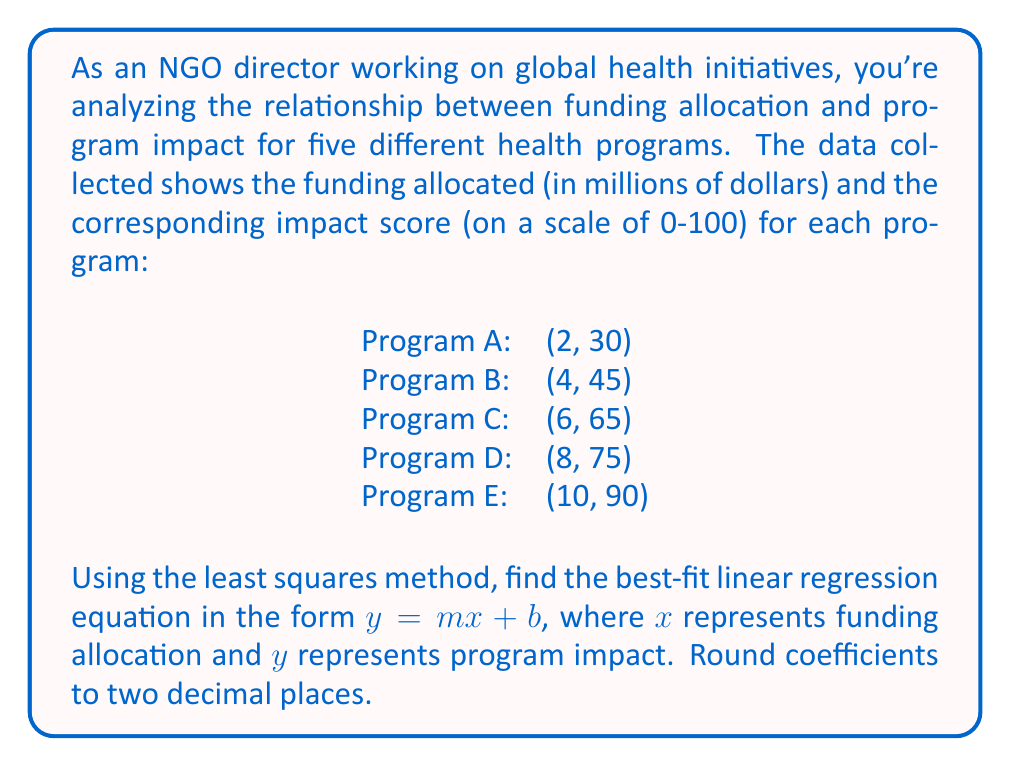Help me with this question. To find the best-fit linear regression equation, we'll use the least squares method. The formulas for calculating the slope (m) and y-intercept (b) are:

$$m = \frac{n\sum xy - \sum x \sum y}{n\sum x^2 - (\sum x)^2}$$

$$b = \frac{\sum y - m\sum x}{n}$$

Where n is the number of data points.

Step 1: Calculate the necessary sums:
$n = 5$
$\sum x = 2 + 4 + 6 + 8 + 10 = 30$
$\sum y = 30 + 45 + 65 + 75 + 90 = 305$
$\sum xy = (2)(30) + (4)(45) + (6)(65) + (8)(75) + (10)(90) = 2,370$
$\sum x^2 = 2^2 + 4^2 + 6^2 + 8^2 + 10^2 = 220$

Step 2: Calculate the slope (m):
$$m = \frac{5(2,370) - (30)(305)}{5(220) - (30)^2}$$
$$m = \frac{11,850 - 9,150}{1,100 - 900}$$
$$m = \frac{2,700}{200} = 13.5$$

Step 3: Calculate the y-intercept (b):
$$b = \frac{305 - 13.5(30)}{5}$$
$$b = \frac{305 - 405}{5} = -20$$

Step 4: Form the linear regression equation:
$y = 13.5x - 20$

Rounding coefficients to two decimal places:
$y = 13.50x - 20.00$
Answer: The best-fit linear regression equation is $y = 13.50x - 20.00$, where $x$ represents funding allocation (in millions of dollars) and $y$ represents program impact score. 